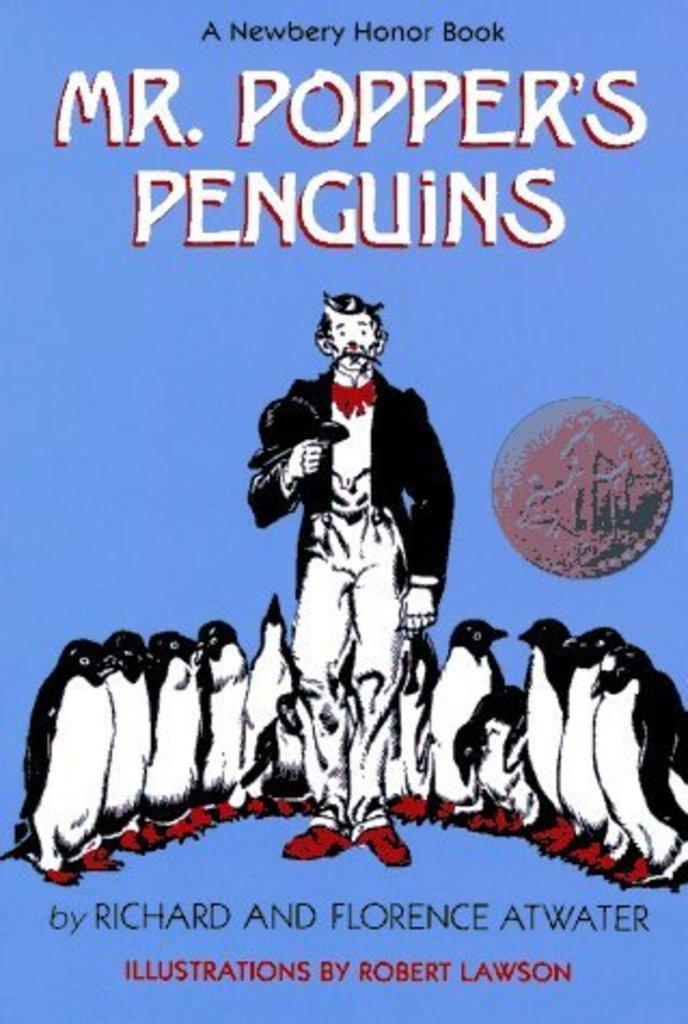<image>
Present a compact description of the photo's key features. The cover of the children's book "Mr. Popper's Penguins". 